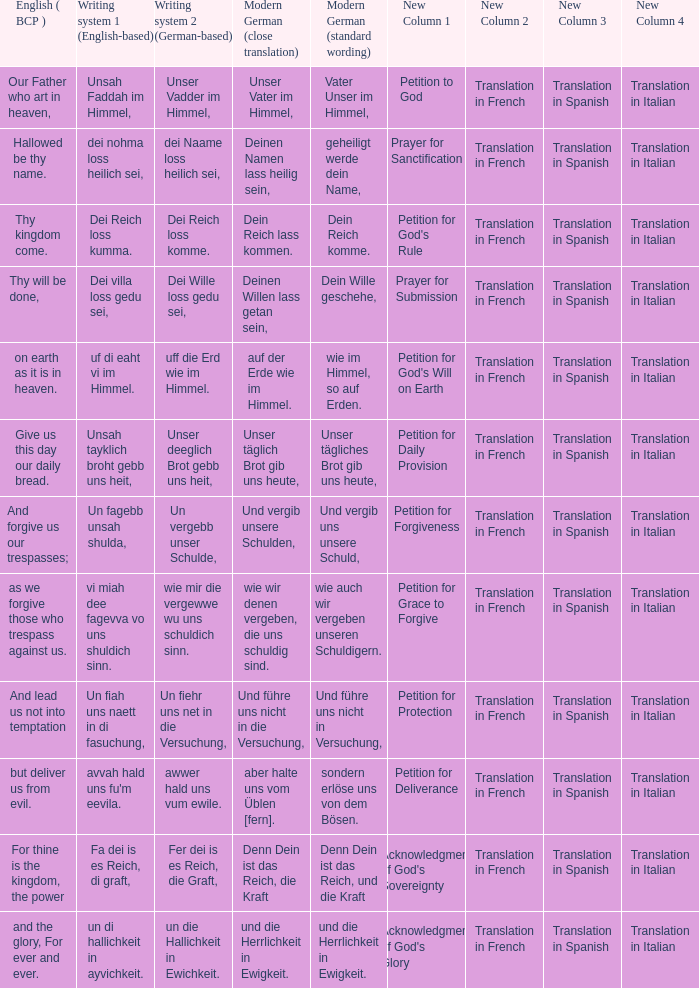What is the modern german standard wording for the german based writing system 2 phrase "wie mir die vergewwe wu uns schuldich sinn."? Wie auch wir vergeben unseren schuldigern. 